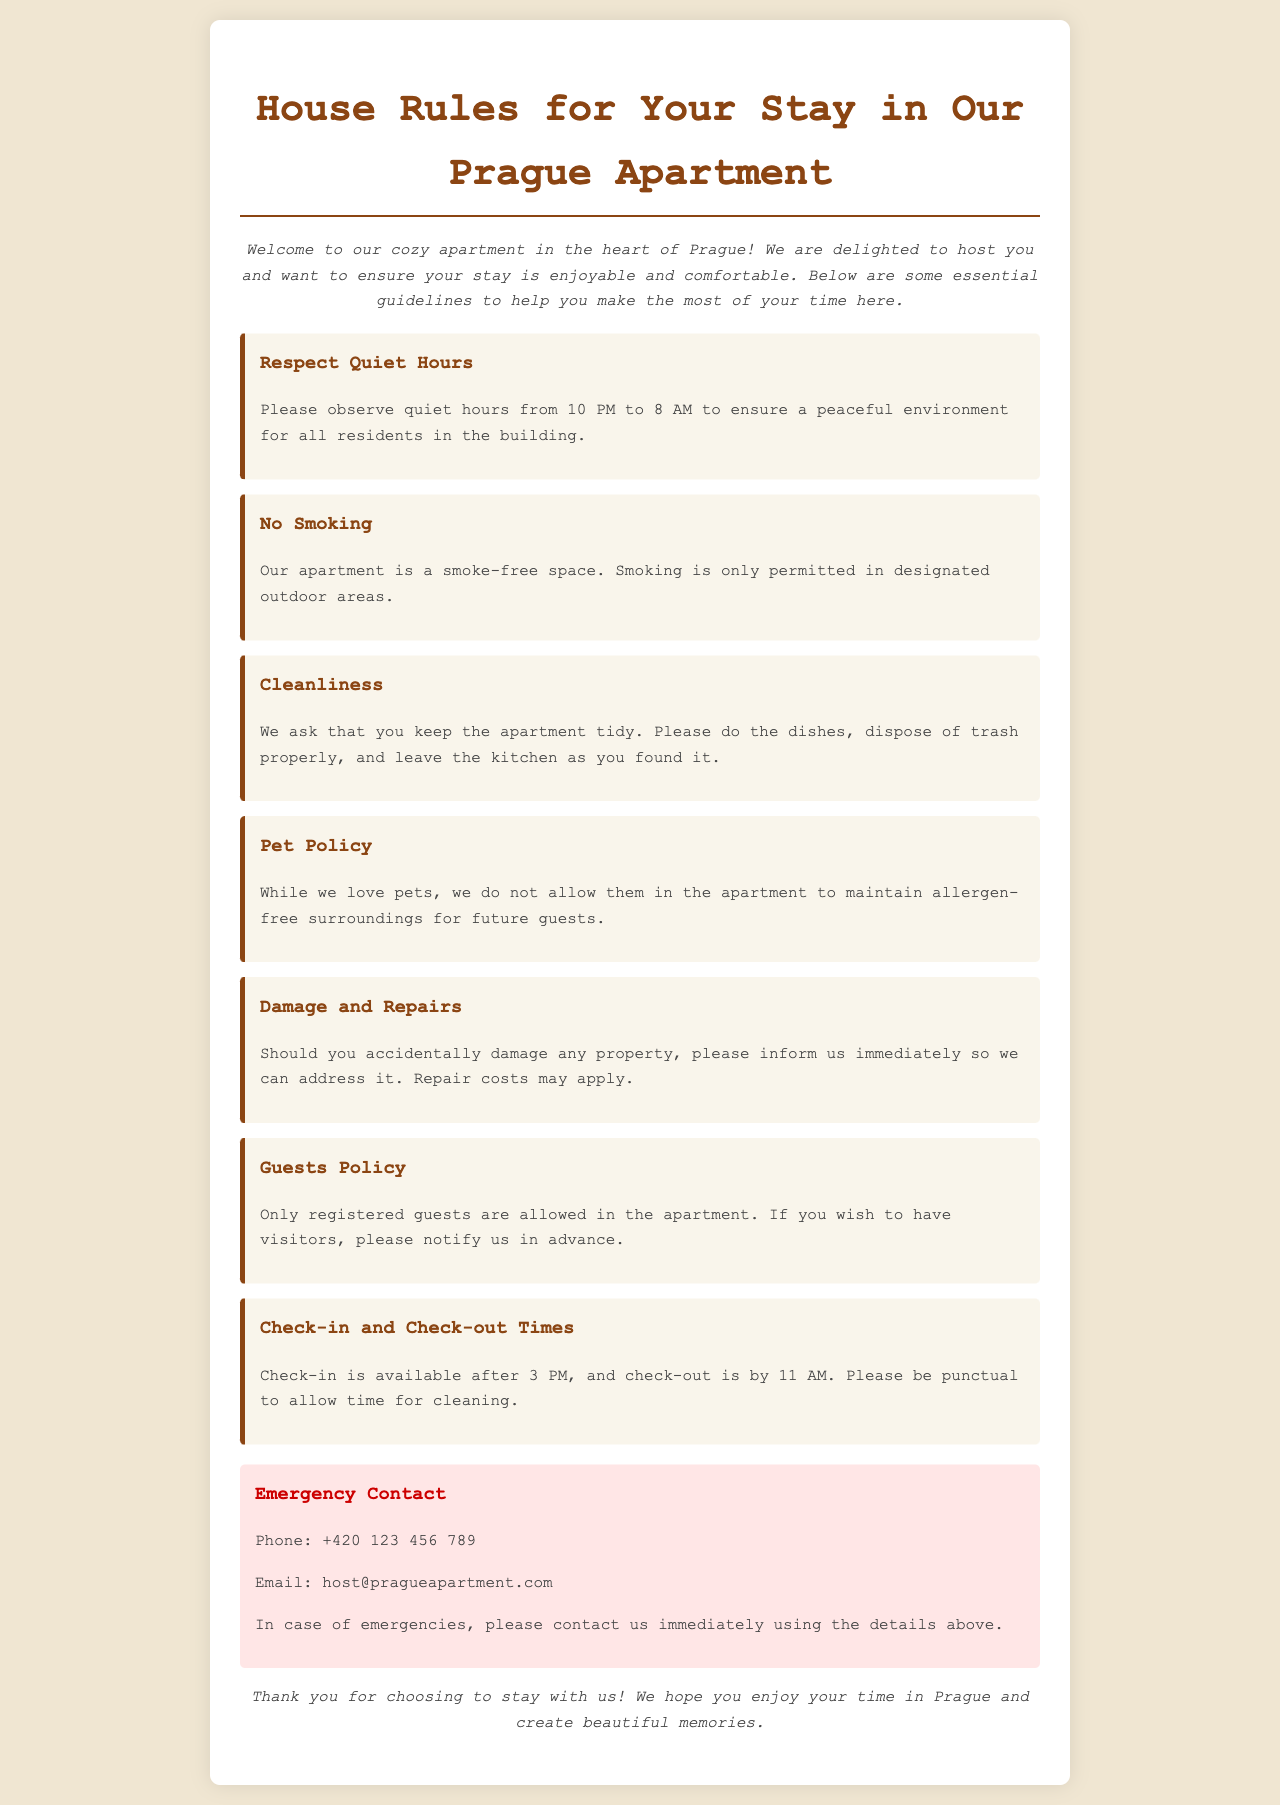What are the quiet hours? The quiet hours are specified in the document as the time during which noise should be minimized, from 10 PM to 8 AM.
Answer: 10 PM to 8 AM Is smoking allowed in the apartment? The document clearly states that smoking is only permitted in designated outdoor areas, implying it is not allowed inside the apartment.
Answer: No smoking What is the check-out time? This information is provided under the check-in and check-out section, indicating the time guests need to leave the apartment.
Answer: 11 AM What phone number should be used for emergencies? The emergency contact section lists a specific phone number to be contacted in case of emergencies.
Answer: +420 123 456 789 Are pets allowed in the apartment? The pet policy mentioned in the document states that pets are not allowed to maintain allergen-free surroundings.
Answer: No What is expected regarding cleanliness during the stay? The cleanliness guideline indicates that guests should keep the apartment tidy by doing dishes and disposing of trash properly.
Answer: Keep the apartment tidy How should guests handle damages? The document states that guests should inform the host immediately if they accidentally damage any property.
Answer: Inform us immediately What is required if guests wish to have visitors? The guests policy specifies that prior notification is required if guests want to have visitors in the apartment.
Answer: Notify us in advance 